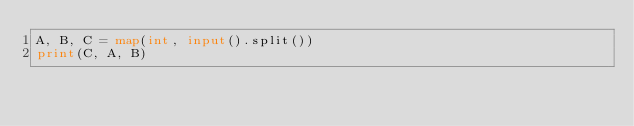<code> <loc_0><loc_0><loc_500><loc_500><_Python_>A, B, C = map(int, input().split())
print(C, A, B)
</code> 